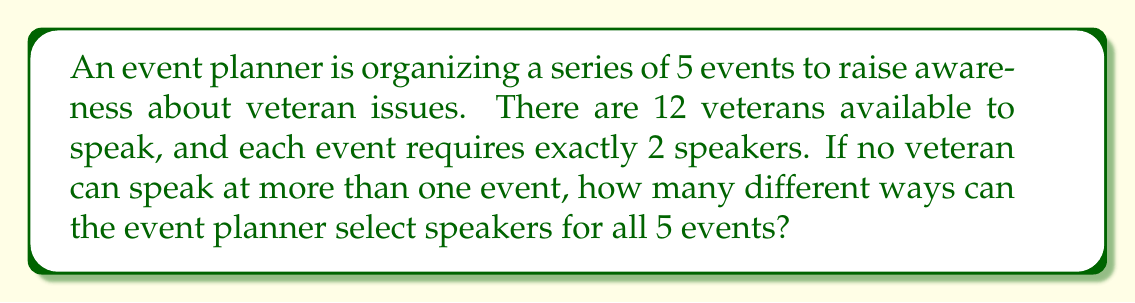Can you solve this math problem? Let's approach this step-by-step:

1) We need to select 2 speakers for each of the 5 events, and no speaker can be repeated. This is a combination problem.

2) For the first event, we need to choose 2 speakers from 12 veterans. This can be done in $\binom{12}{2}$ ways.

3) For the second event, we have 10 remaining veterans, so we choose 2 from 10: $\binom{10}{2}$ ways.

4) Continuing this pattern, for the third event we choose from 8, for the fourth from 6, and for the fifth from 4.

5) By the multiplication principle, the total number of ways to select speakers for all events is:

   $$\binom{12}{2} \cdot \binom{10}{2} \cdot \binom{8}{2} \cdot \binom{6}{2} \cdot \binom{4}{2}$$

6) Let's calculate each combination:
   
   $\binom{12}{2} = 66$
   $\binom{10}{2} = 45$
   $\binom{8}{2} = 28$
   $\binom{6}{2} = 15$
   $\binom{4}{2} = 6$

7) Multiplying these together:

   $66 \cdot 45 \cdot 28 \cdot 15 \cdot 6 = 11,907,600$

Therefore, there are 11,907,600 different ways to select speakers for all 5 events.
Answer: 11,907,600 